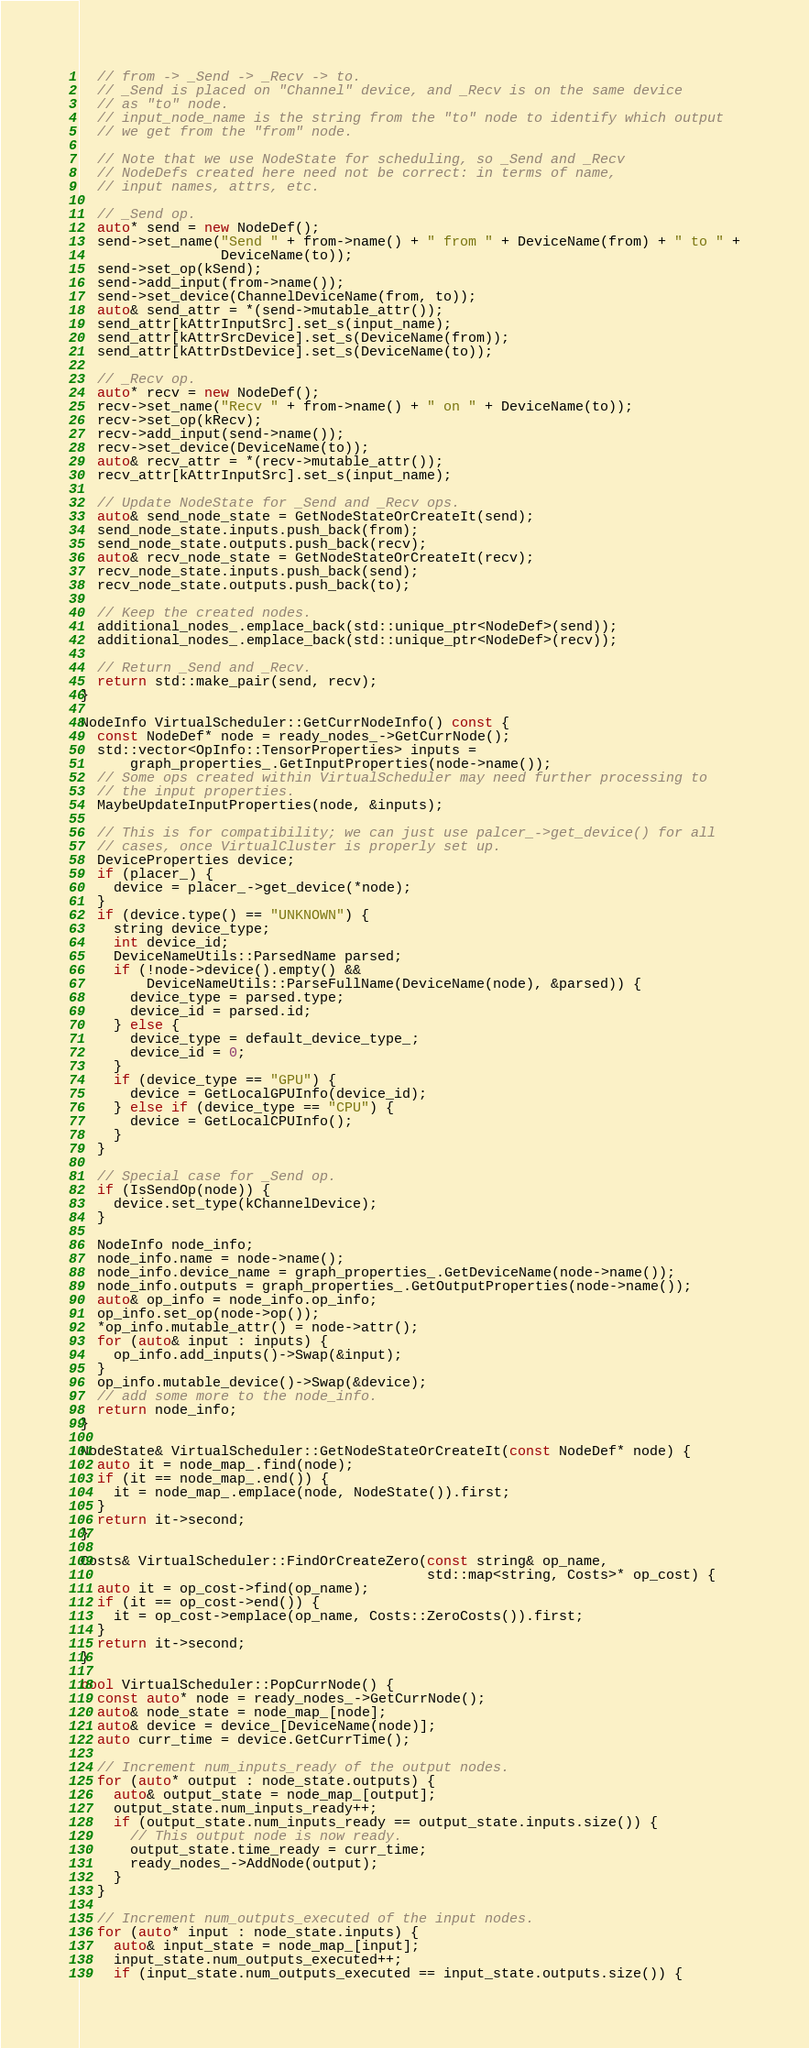Convert code to text. <code><loc_0><loc_0><loc_500><loc_500><_C++_>  // from -> _Send -> _Recv -> to.
  // _Send is placed on "Channel" device, and _Recv is on the same device
  // as "to" node.
  // input_node_name is the string from the "to" node to identify which output
  // we get from the "from" node.

  // Note that we use NodeState for scheduling, so _Send and _Recv
  // NodeDefs created here need not be correct: in terms of name,
  // input names, attrs, etc.

  // _Send op.
  auto* send = new NodeDef();
  send->set_name("Send " + from->name() + " from " + DeviceName(from) + " to " +
                 DeviceName(to));
  send->set_op(kSend);
  send->add_input(from->name());
  send->set_device(ChannelDeviceName(from, to));
  auto& send_attr = *(send->mutable_attr());
  send_attr[kAttrInputSrc].set_s(input_name);
  send_attr[kAttrSrcDevice].set_s(DeviceName(from));
  send_attr[kAttrDstDevice].set_s(DeviceName(to));

  // _Recv op.
  auto* recv = new NodeDef();
  recv->set_name("Recv " + from->name() + " on " + DeviceName(to));
  recv->set_op(kRecv);
  recv->add_input(send->name());
  recv->set_device(DeviceName(to));
  auto& recv_attr = *(recv->mutable_attr());
  recv_attr[kAttrInputSrc].set_s(input_name);

  // Update NodeState for _Send and _Recv ops.
  auto& send_node_state = GetNodeStateOrCreateIt(send);
  send_node_state.inputs.push_back(from);
  send_node_state.outputs.push_back(recv);
  auto& recv_node_state = GetNodeStateOrCreateIt(recv);
  recv_node_state.inputs.push_back(send);
  recv_node_state.outputs.push_back(to);

  // Keep the created nodes.
  additional_nodes_.emplace_back(std::unique_ptr<NodeDef>(send));
  additional_nodes_.emplace_back(std::unique_ptr<NodeDef>(recv));

  // Return _Send and _Recv.
  return std::make_pair(send, recv);
}

NodeInfo VirtualScheduler::GetCurrNodeInfo() const {
  const NodeDef* node = ready_nodes_->GetCurrNode();
  std::vector<OpInfo::TensorProperties> inputs =
      graph_properties_.GetInputProperties(node->name());
  // Some ops created within VirtualScheduler may need further processing to
  // the input properties.
  MaybeUpdateInputProperties(node, &inputs);

  // This is for compatibility; we can just use palcer_->get_device() for all
  // cases, once VirtualCluster is properly set up.
  DeviceProperties device;
  if (placer_) {
    device = placer_->get_device(*node);
  }
  if (device.type() == "UNKNOWN") {
    string device_type;
    int device_id;
    DeviceNameUtils::ParsedName parsed;
    if (!node->device().empty() &&
        DeviceNameUtils::ParseFullName(DeviceName(node), &parsed)) {
      device_type = parsed.type;
      device_id = parsed.id;
    } else {
      device_type = default_device_type_;
      device_id = 0;
    }
    if (device_type == "GPU") {
      device = GetLocalGPUInfo(device_id);
    } else if (device_type == "CPU") {
      device = GetLocalCPUInfo();
    }
  }

  // Special case for _Send op.
  if (IsSendOp(node)) {
    device.set_type(kChannelDevice);
  }

  NodeInfo node_info;
  node_info.name = node->name();
  node_info.device_name = graph_properties_.GetDeviceName(node->name());
  node_info.outputs = graph_properties_.GetOutputProperties(node->name());
  auto& op_info = node_info.op_info;
  op_info.set_op(node->op());
  *op_info.mutable_attr() = node->attr();
  for (auto& input : inputs) {
    op_info.add_inputs()->Swap(&input);
  }
  op_info.mutable_device()->Swap(&device);
  // add some more to the node_info.
  return node_info;
}

NodeState& VirtualScheduler::GetNodeStateOrCreateIt(const NodeDef* node) {
  auto it = node_map_.find(node);
  if (it == node_map_.end()) {
    it = node_map_.emplace(node, NodeState()).first;
  }
  return it->second;
}

Costs& VirtualScheduler::FindOrCreateZero(const string& op_name,
                                          std::map<string, Costs>* op_cost) {
  auto it = op_cost->find(op_name);
  if (it == op_cost->end()) {
    it = op_cost->emplace(op_name, Costs::ZeroCosts()).first;
  }
  return it->second;
}

bool VirtualScheduler::PopCurrNode() {
  const auto* node = ready_nodes_->GetCurrNode();
  auto& node_state = node_map_[node];
  auto& device = device_[DeviceName(node)];
  auto curr_time = device.GetCurrTime();

  // Increment num_inputs_ready of the output nodes.
  for (auto* output : node_state.outputs) {
    auto& output_state = node_map_[output];
    output_state.num_inputs_ready++;
    if (output_state.num_inputs_ready == output_state.inputs.size()) {
      // This output node is now ready.
      output_state.time_ready = curr_time;
      ready_nodes_->AddNode(output);
    }
  }

  // Increment num_outputs_executed of the input nodes.
  for (auto* input : node_state.inputs) {
    auto& input_state = node_map_[input];
    input_state.num_outputs_executed++;
    if (input_state.num_outputs_executed == input_state.outputs.size()) {</code> 